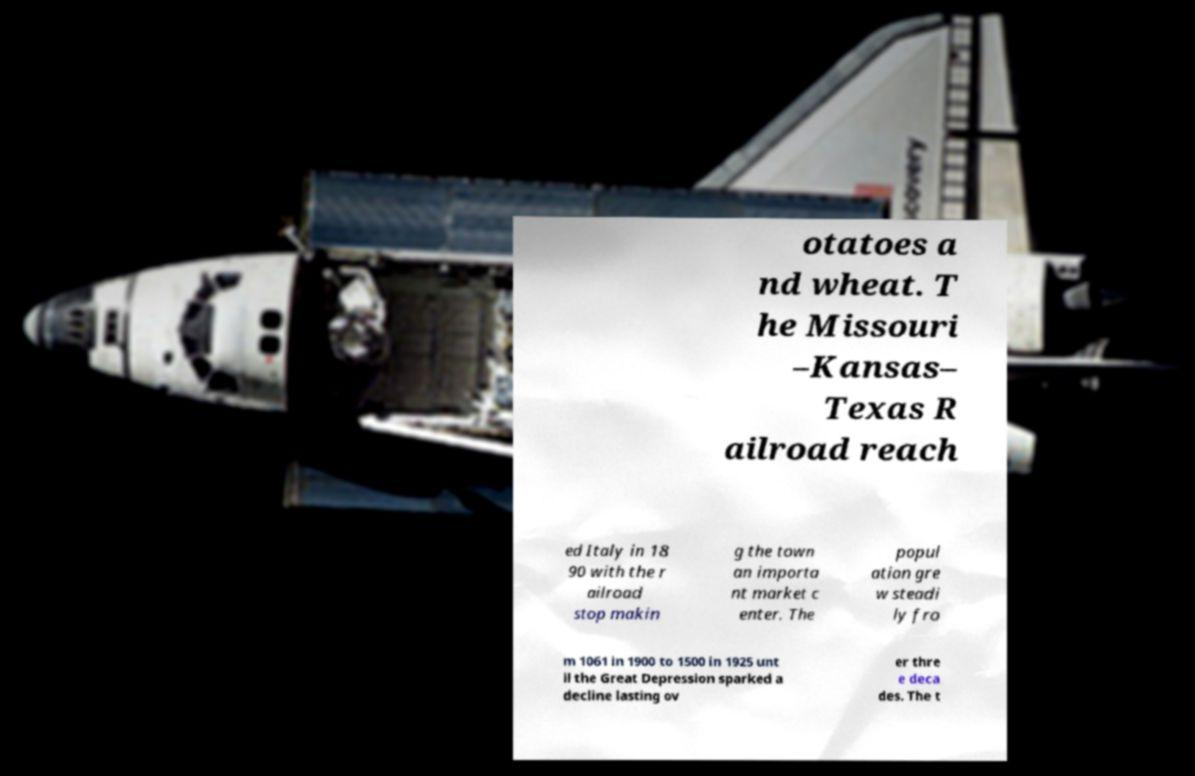For documentation purposes, I need the text within this image transcribed. Could you provide that? otatoes a nd wheat. T he Missouri –Kansas– Texas R ailroad reach ed Italy in 18 90 with the r ailroad stop makin g the town an importa nt market c enter. The popul ation gre w steadi ly fro m 1061 in 1900 to 1500 in 1925 unt il the Great Depression sparked a decline lasting ov er thre e deca des. The t 